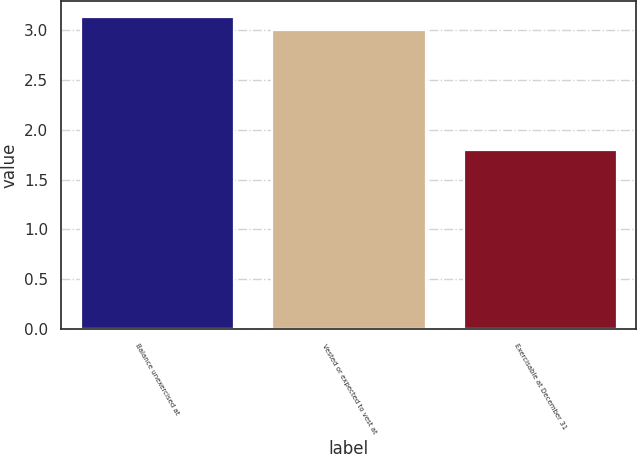<chart> <loc_0><loc_0><loc_500><loc_500><bar_chart><fcel>Balance unexercised at<fcel>Vested or expected to vest at<fcel>Exercisable at December 31<nl><fcel>3.13<fcel>3<fcel>1.8<nl></chart> 